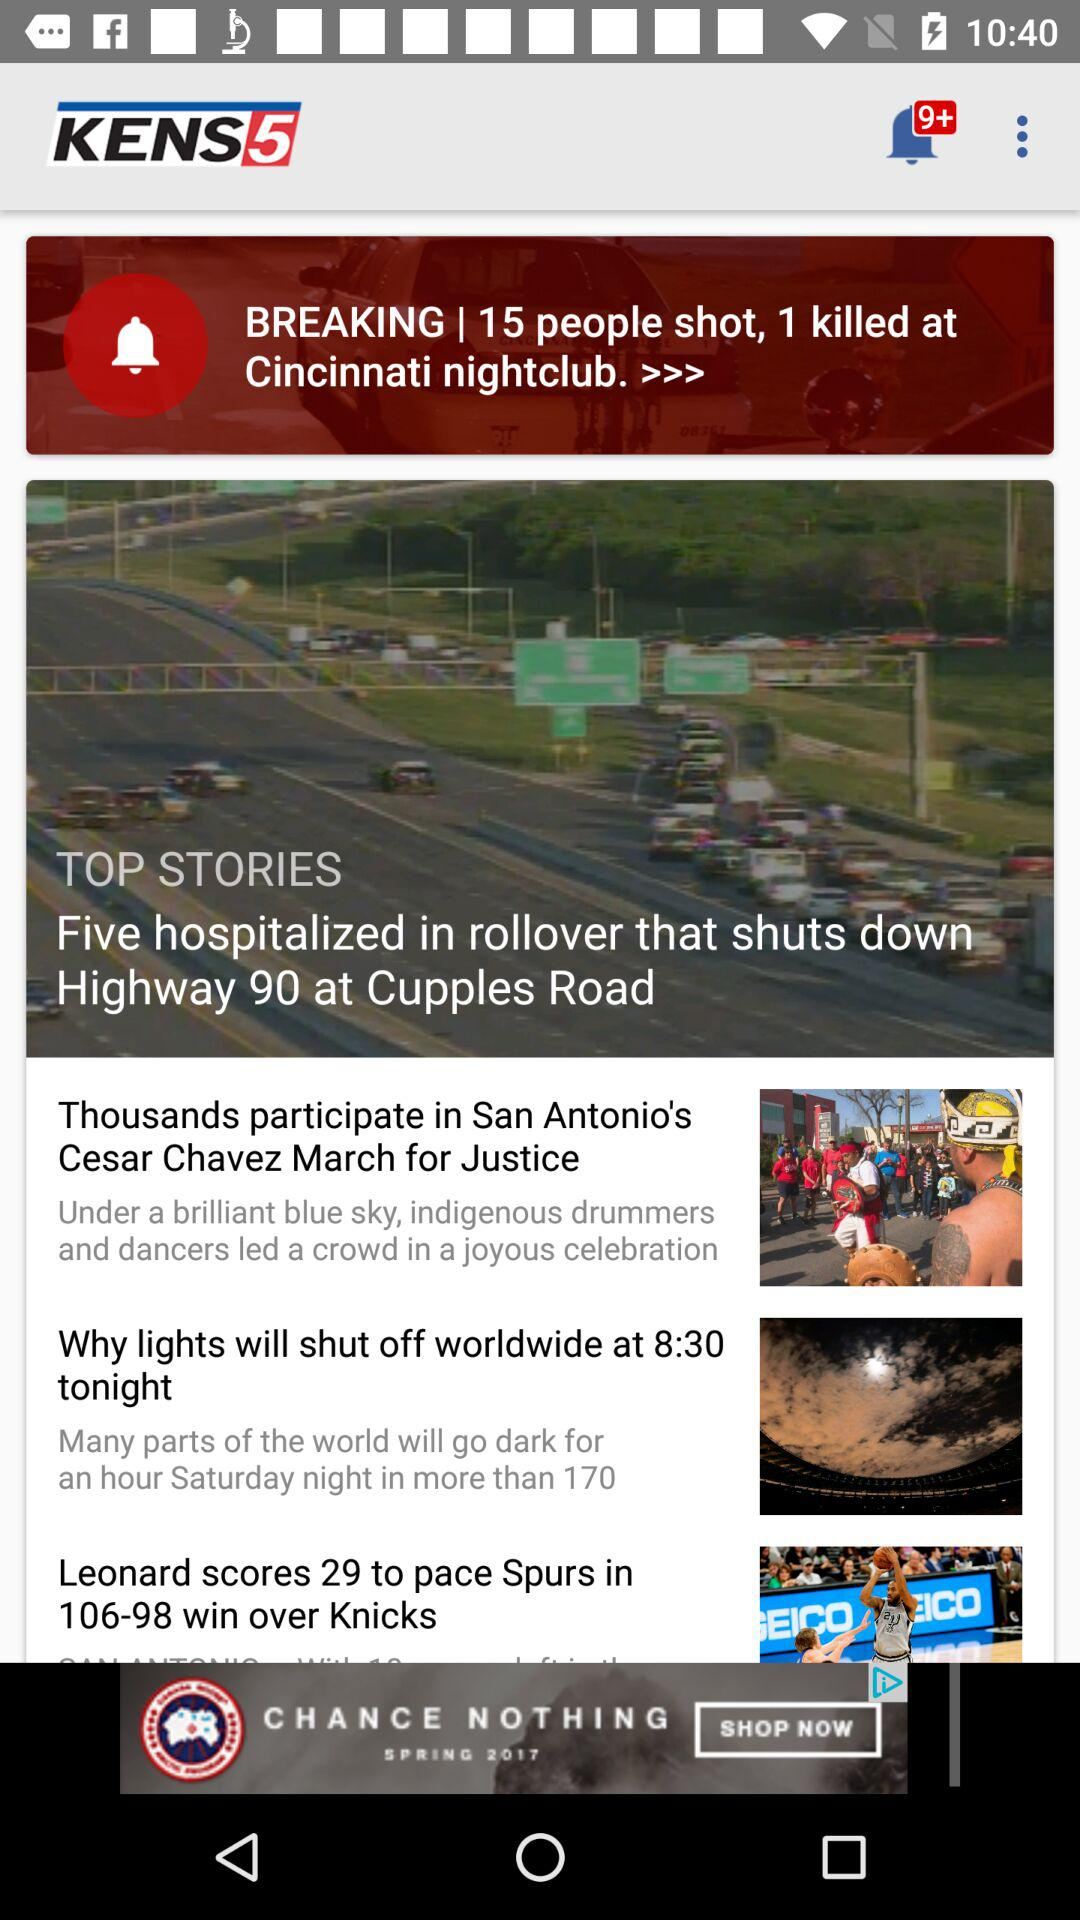How many notifications are there? There are more than 9 notifications. 